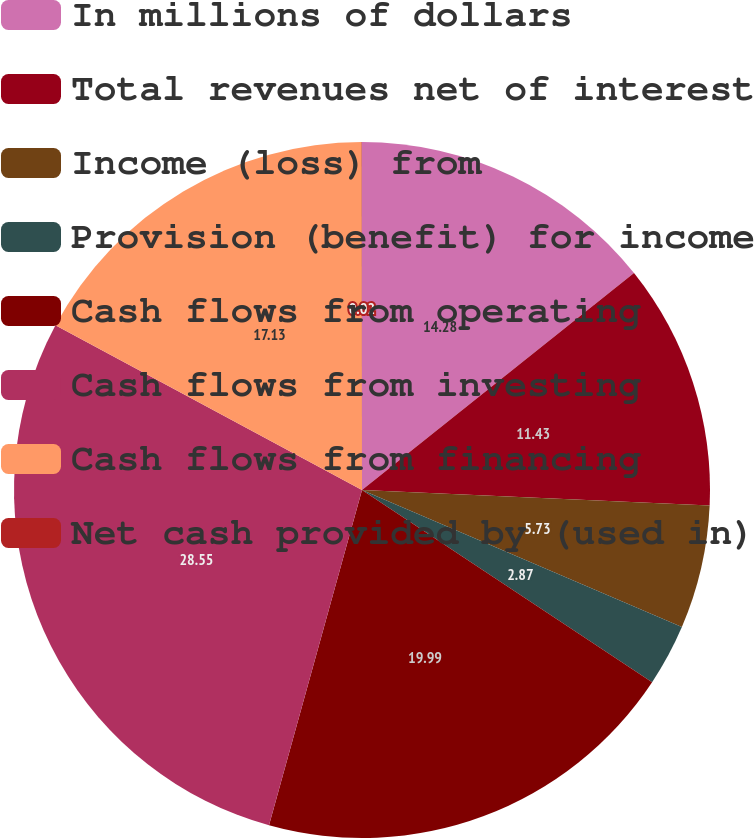Convert chart to OTSL. <chart><loc_0><loc_0><loc_500><loc_500><pie_chart><fcel>In millions of dollars<fcel>Total revenues net of interest<fcel>Income (loss) from<fcel>Provision (benefit) for income<fcel>Cash flows from operating<fcel>Cash flows from investing<fcel>Cash flows from financing<fcel>Net cash provided by (used in)<nl><fcel>14.28%<fcel>11.43%<fcel>5.73%<fcel>2.87%<fcel>19.99%<fcel>28.54%<fcel>17.13%<fcel>0.02%<nl></chart> 